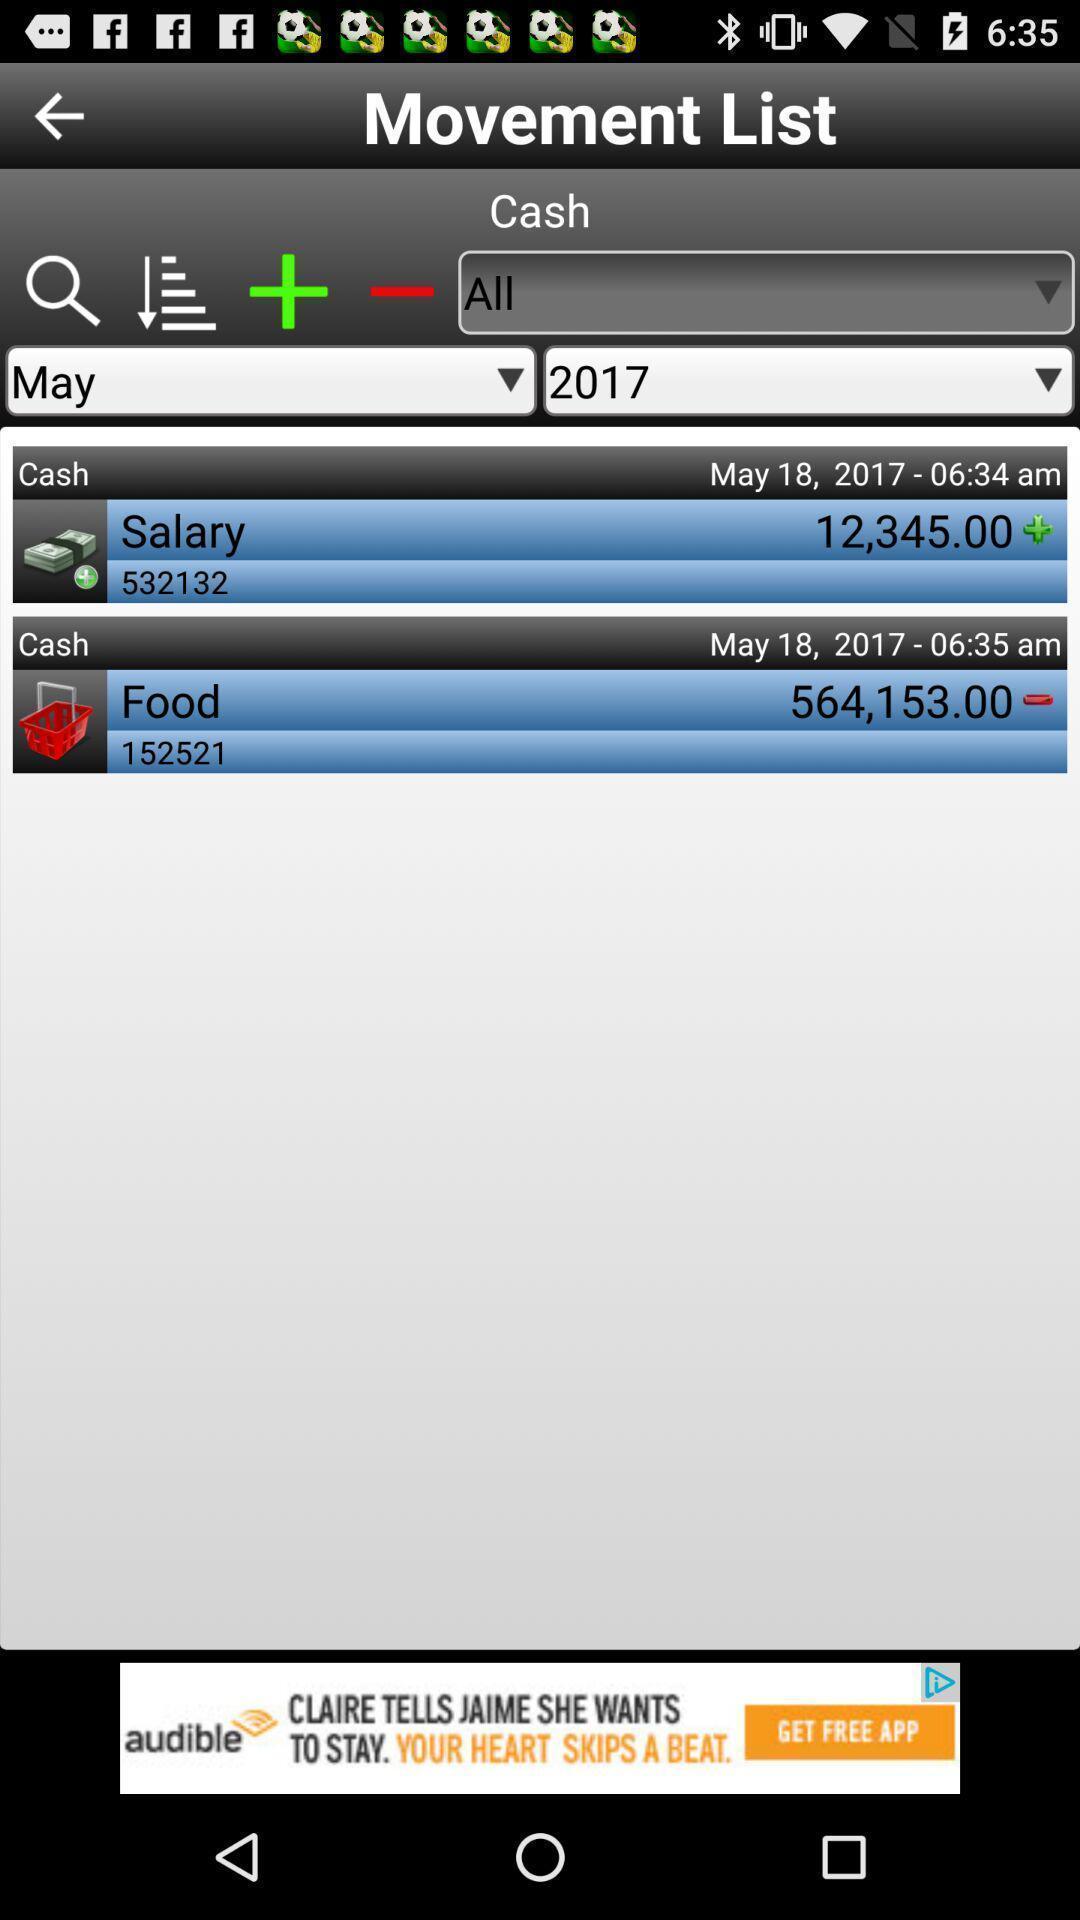Describe the visual elements of this screenshot. Page displaying movement list in the app. 